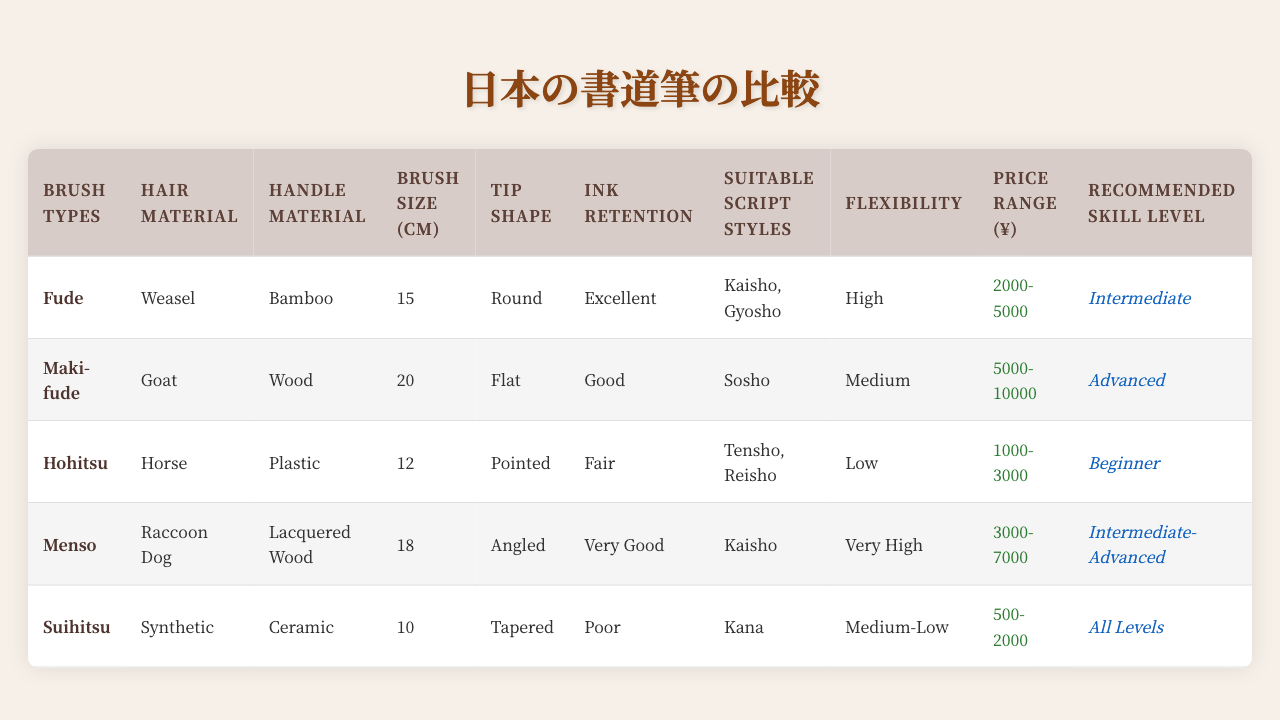What type of hair material is used in the Hohitsu brush? The Hohitsu brush is listed under hair material and it indicates "Raccoon Dog" as its hair material.
Answer: Raccoon Dog Which brush has the smallest size? By checking the brush sizes listed, the Suihitsu brush has a size of 10 cm, which is smaller than all others.
Answer: Suihitsu Is the Maki-fude brush suitable for beginners? The recommended skill level for Maki-fude is "Advanced," indicating it is not suitable for beginners.
Answer: No What is the average price range of all the brush types? To find the average, first, we convert the price ranges to numerical values: (3500 + 7500 + 2000 + 5000 + 1250) / 5 = 5000. The midpoint for these ranges will give us the average price of ¥5000.
Answer: ¥5000 Which brush type has the best ink retention and what is its price range? The Brush type with the best ink retention is Fude with "Excellent" ink retention. Its price range is ¥2000-5000.
Answer: Fude, ¥2000-5000 How many brush types are suitable for Kaisho script styles? From the listed suitable script styles, both Fude and Menso are suitable for Kaisho, totaling two brush types.
Answer: 2 Do any brushes have a Low flexibility rating? When checking the flexibility ratings, the only brush that has a Low rating is Menso.
Answer: Yes Which brush types are made from synthetic hair material? The table indicates that the Suihitsu brush is the only one made with synthetic hair material.
Answer: Suihitsu What is the recommended skill level for the most flexible brush? To determine this, we look at the flexibility ratings and find that Maki-fude has "High" flexibility. Its recommended skill level is "Advanced."
Answer: Advanced Which brush type is the most suitable for Kana script styles? Looking at the suitable script styles, the Suihitsu brush is explicitly noted for Kana, confirming that it is the most suitable.
Answer: Suihitsu 